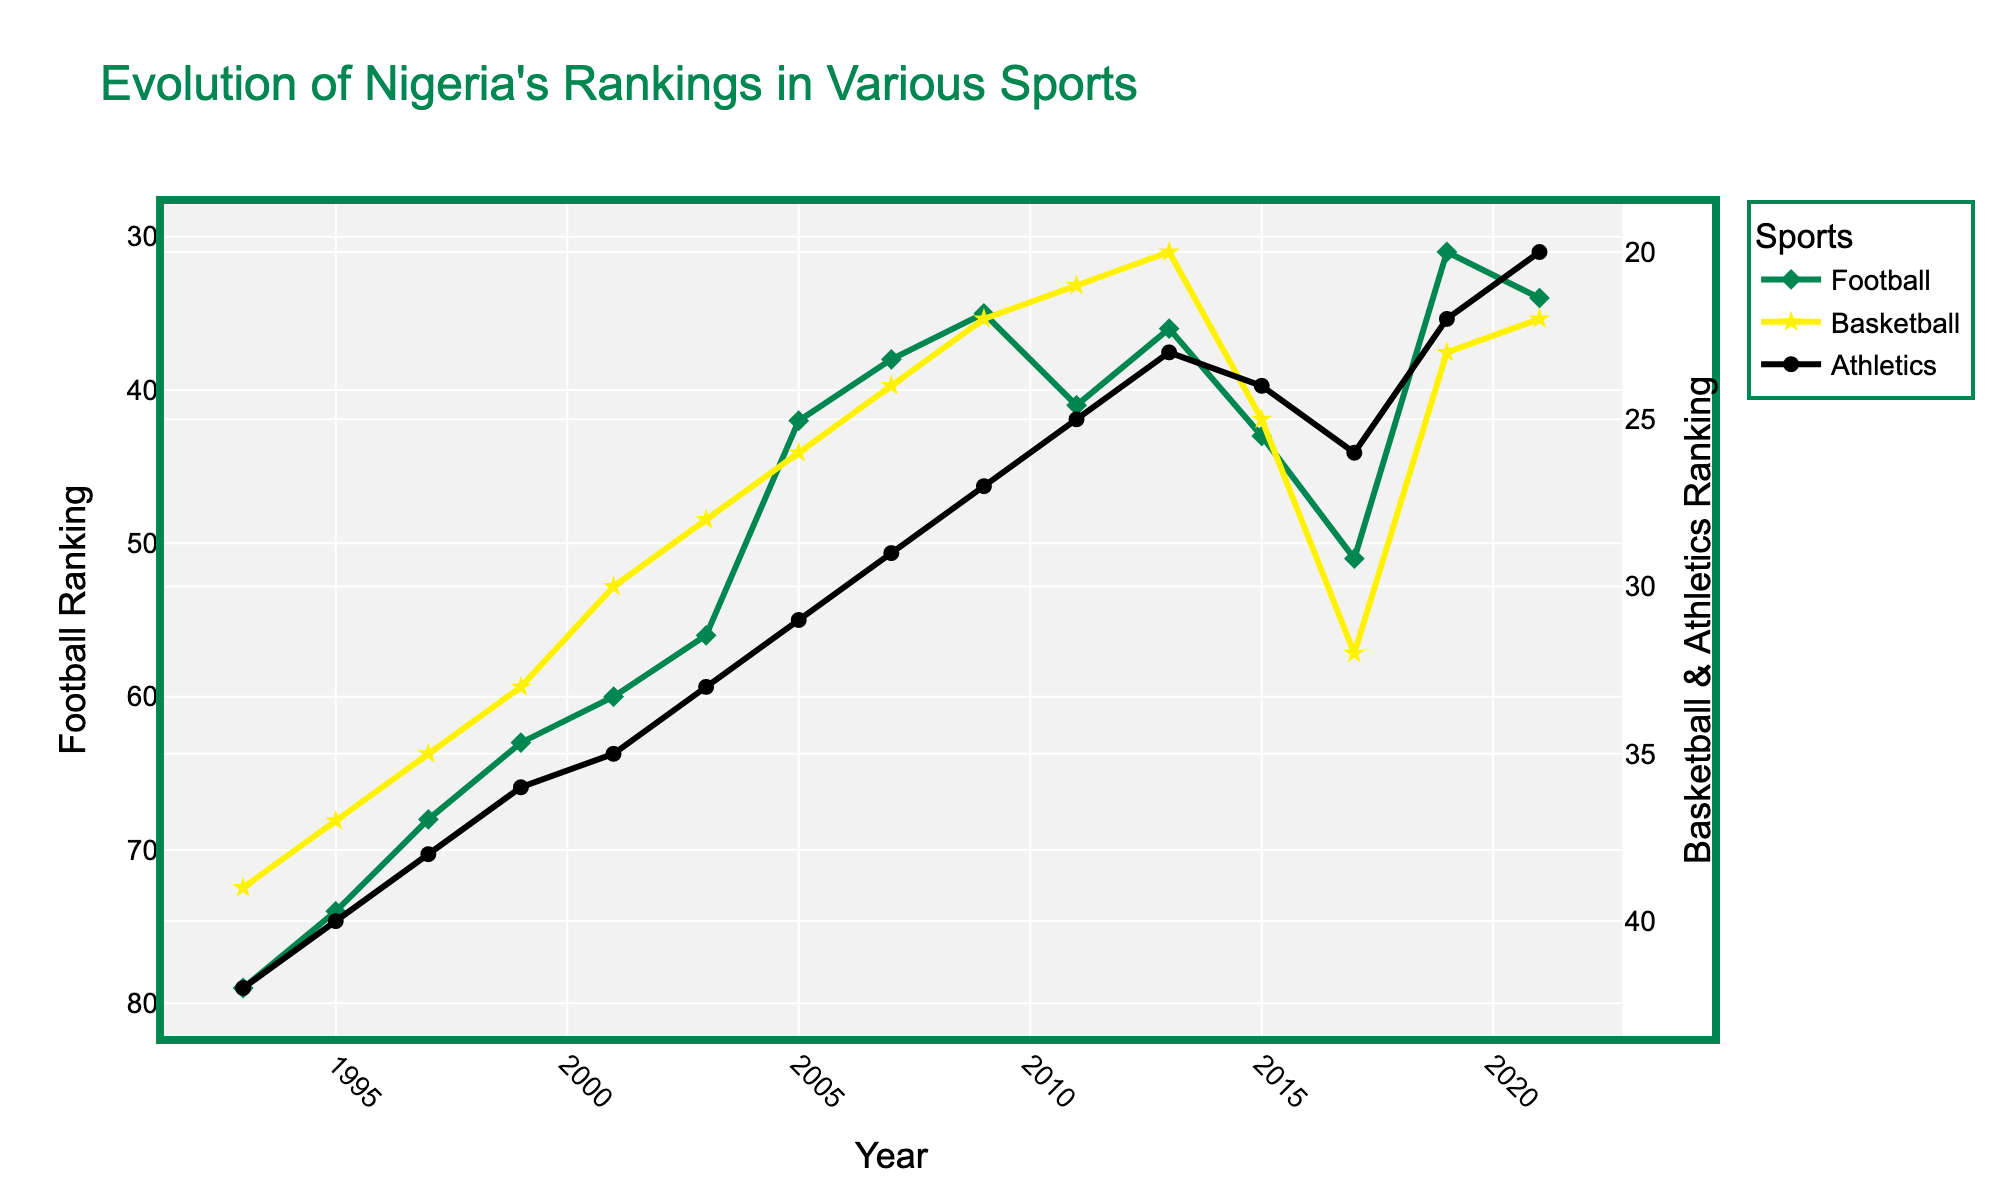Which year did Nigeria's football team achieve its best FIFA ranking? Look at the "Football" (green line with diamond markers) data points to identify the year with the lowest ranking number.
Answer: 2019 Between 1993 and 2021, in which year did Nigeria's basketball ranking achieve the highest position? Check the "Basketball" (yellow line with star markers) data points to find the year with the lowest ranking number.
Answer: 2013 How did Nigeria's athletics ranking change from 2007 to 2015? Observe the "Athletics" (black line with circle markers) data points for the years 2007 and 2015 to see if the ranking number increased, decreased, or remained the same from 29 to 24.
Answer: Improved What is the average FIFA ranking for Nigeria's football team between 2011 and 2021? Identify the "Football" data points for 2011 to 2021: 41, 36, 43, 51, 31, 34. Sum these values and divide by the number of years. (41 + 36 + 43 + 51 + 31 + 34) / 6 = 39.33
Answer: 39.33 Which sport saw the most consistent improvement in rankings over the years? Compare the trends of all three lines (green for football, yellow for basketball, black for athletics). The sport with the most steady decrease in ranking position shows the most consistent improvement.
Answer: Basketball In which year did Nigeria's athletics team achieve the same rank as in 1993? Look for the year in the "Athletics" data where the ranking number matches 1993 (42).
Answer: None Compare Nigeria's football and basketball rankings in 2017. Which was better? Locate the "Football" and "Basketball" data points for 2017: 51 for football and 32 for basketball. A lower number indicates a better ranking.
Answer: Basketball What was the difference in Nigeria's basketball ranking between 2009 and 2021? Find the "Basketball" rankings for 2009 and 2021: 22 and 22 respectively. Calculate the difference: 22 - 22 = 0.
Answer: 0 How did Nigeria's football ranking trend from 2003 to 2007? Examine the "Football" data points for 2003, 2005, and 2007: 56, 42, and 38. Identify whether the rankings are improving, worsening, or stable.
Answer: Improved 